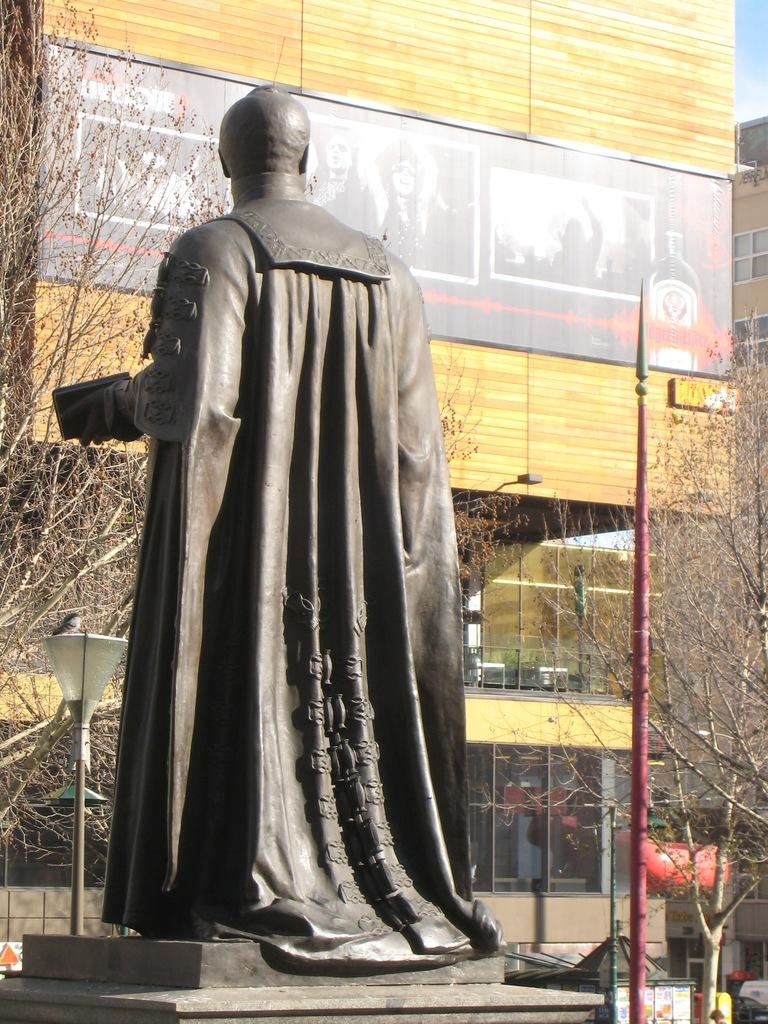What is the main subject in the image? There is a statue in the image. What else can be seen in the image besides the statue? There are buildings, trees, and a pole light in the image. What is the condition of the sky in the image? The sky is blue and cloudy in the image. Can you tell me how many squirrels are climbing the statue in the image? There are no squirrels present in the image; it only features a statue, buildings, trees, a pole light, and a blue and cloudy sky. What is the increase in the size of the statue's mouth in the image? There is no mention of the statue's mouth or any changes in size in the provided facts, and the image does not show any such details. 